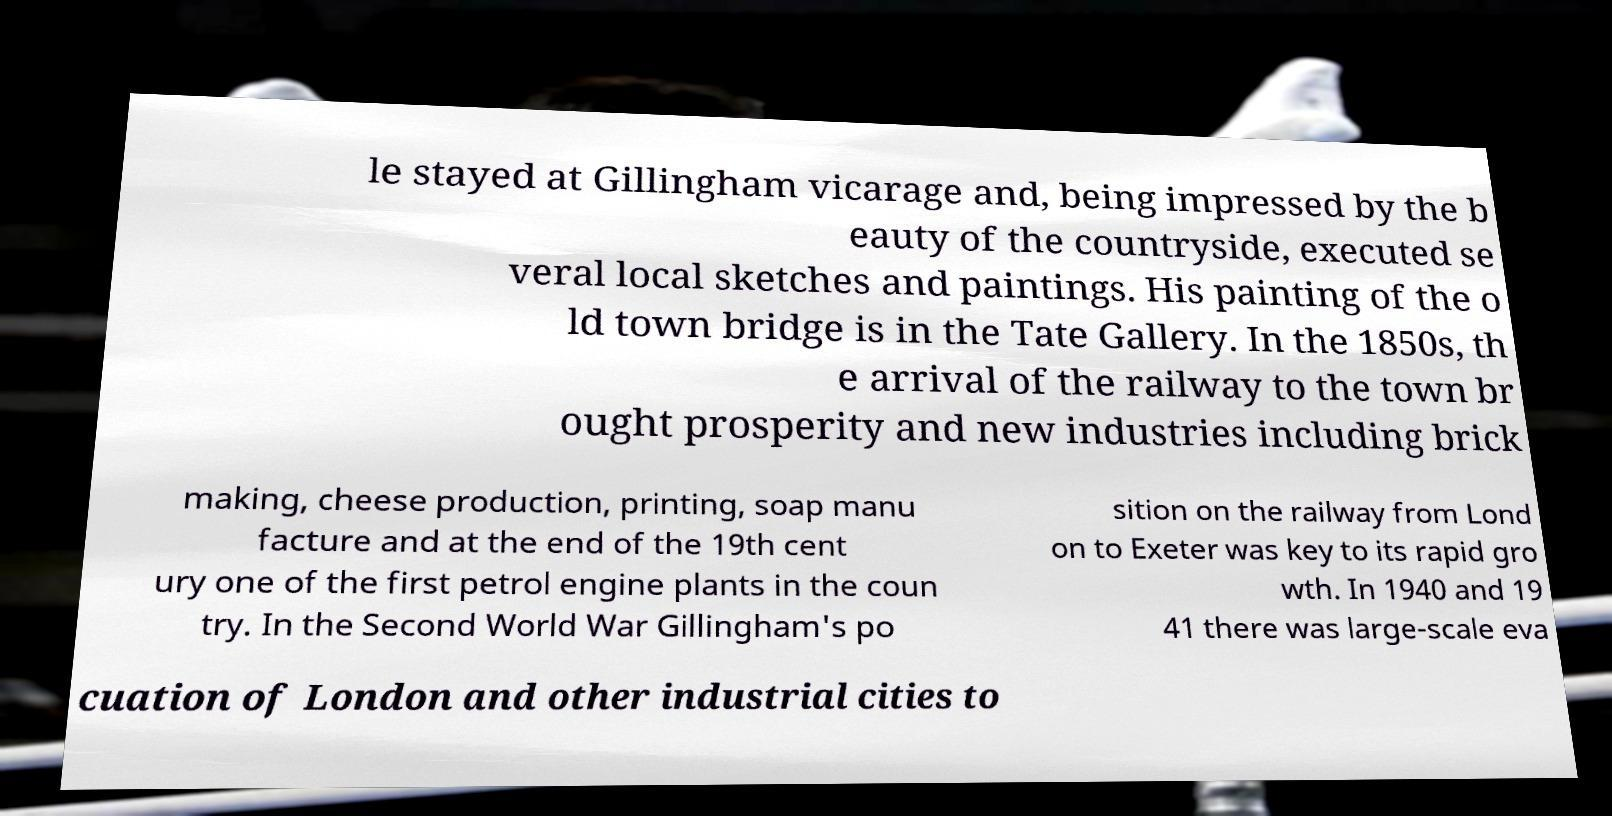What messages or text are displayed in this image? I need them in a readable, typed format. le stayed at Gillingham vicarage and, being impressed by the b eauty of the countryside, executed se veral local sketches and paintings. His painting of the o ld town bridge is in the Tate Gallery. In the 1850s, th e arrival of the railway to the town br ought prosperity and new industries including brick making, cheese production, printing, soap manu facture and at the end of the 19th cent ury one of the first petrol engine plants in the coun try. In the Second World War Gillingham's po sition on the railway from Lond on to Exeter was key to its rapid gro wth. In 1940 and 19 41 there was large-scale eva cuation of London and other industrial cities to 